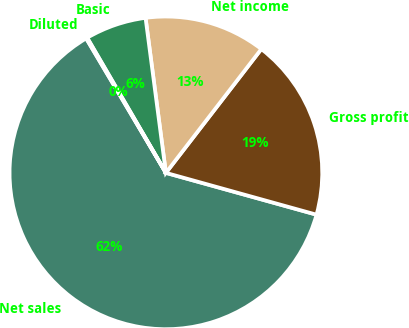<chart> <loc_0><loc_0><loc_500><loc_500><pie_chart><fcel>Net sales<fcel>Gross profit<fcel>Net income<fcel>Basic<fcel>Diluted<nl><fcel>62.18%<fcel>18.86%<fcel>12.53%<fcel>6.32%<fcel>0.12%<nl></chart> 